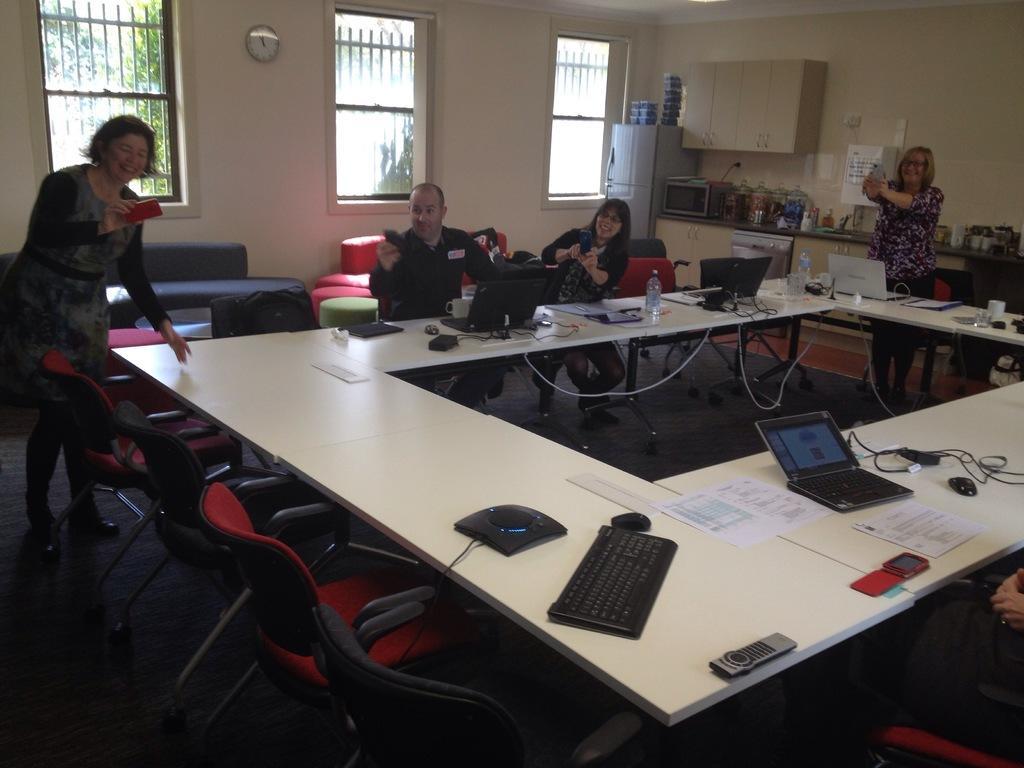Please provide a concise description of this image. In this image I see 4 persons, in which 2 of them are standing and 2 of them are sitting and all of them are holding their mobile phones and smiling. I can also see there are lot of chairs and tables in front on which there are few things on it. In the background I see the windows, cabinets, refrigerator, Owen and the wall. 